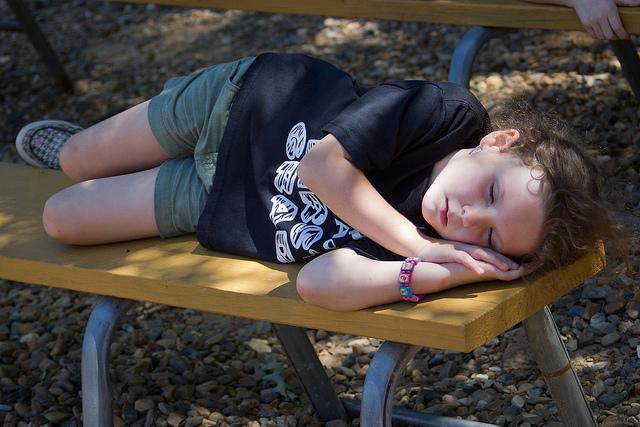How many elephants are walking?
Give a very brief answer. 0. 